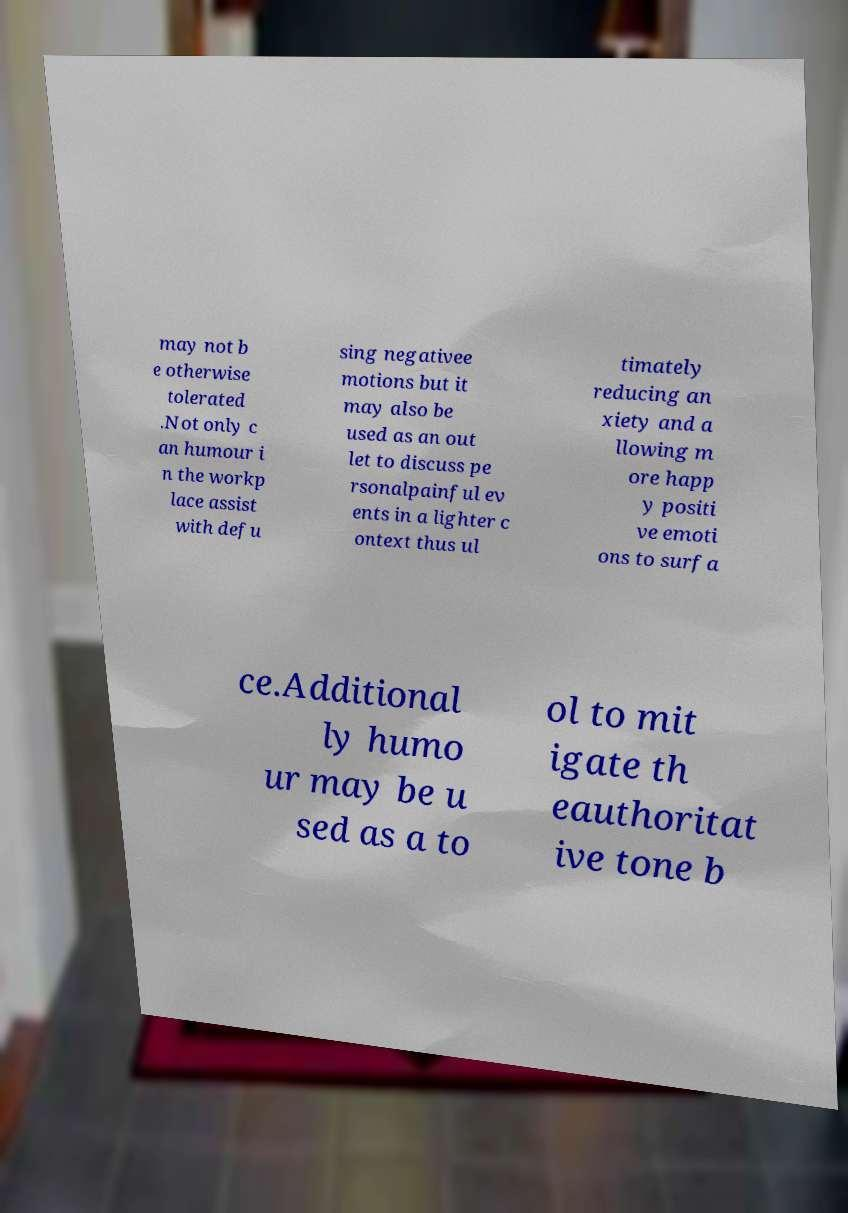For documentation purposes, I need the text within this image transcribed. Could you provide that? may not b e otherwise tolerated .Not only c an humour i n the workp lace assist with defu sing negativee motions but it may also be used as an out let to discuss pe rsonalpainful ev ents in a lighter c ontext thus ul timately reducing an xiety and a llowing m ore happ y positi ve emoti ons to surfa ce.Additional ly humo ur may be u sed as a to ol to mit igate th eauthoritat ive tone b 